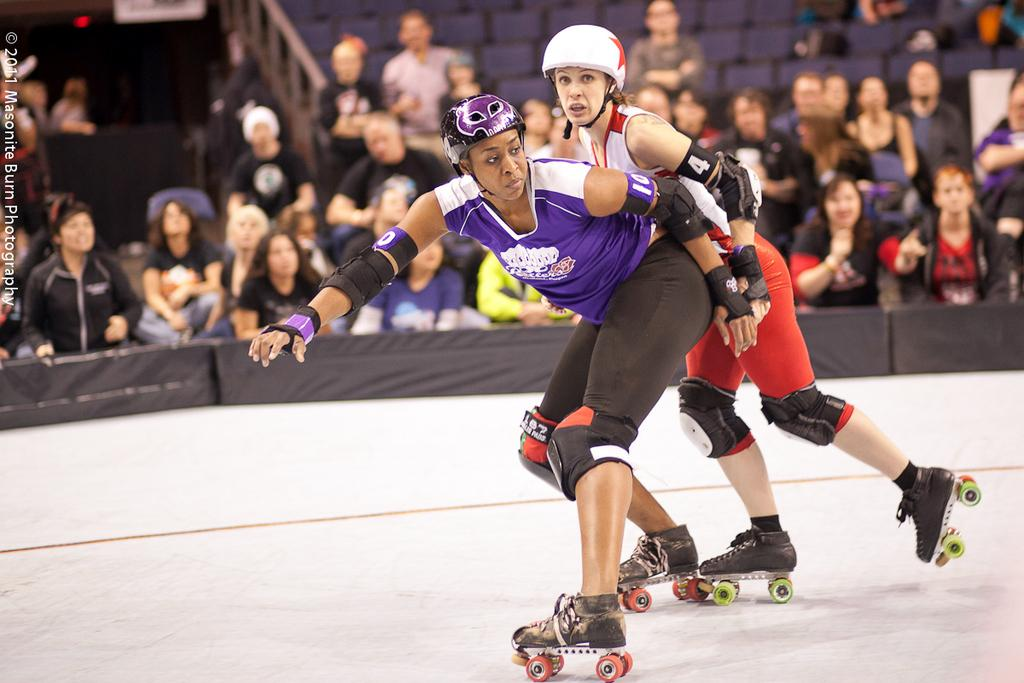What are the two persons on in the image? The two persons are on skating boards. What safety equipment are the persons wearing? The persons are wearing helmets. What can be seen in the background of the image? There is a crowd of people in the background. Where is the text located in the image? The text is on the left side of the image. What type of crow is perched on the skating board in the image? There is no crow present in the image; the two persons are on skating boards without any birds. What kind of waves can be seen in the background of the image? There are no waves visible in the image; the background features a crowd of people. 